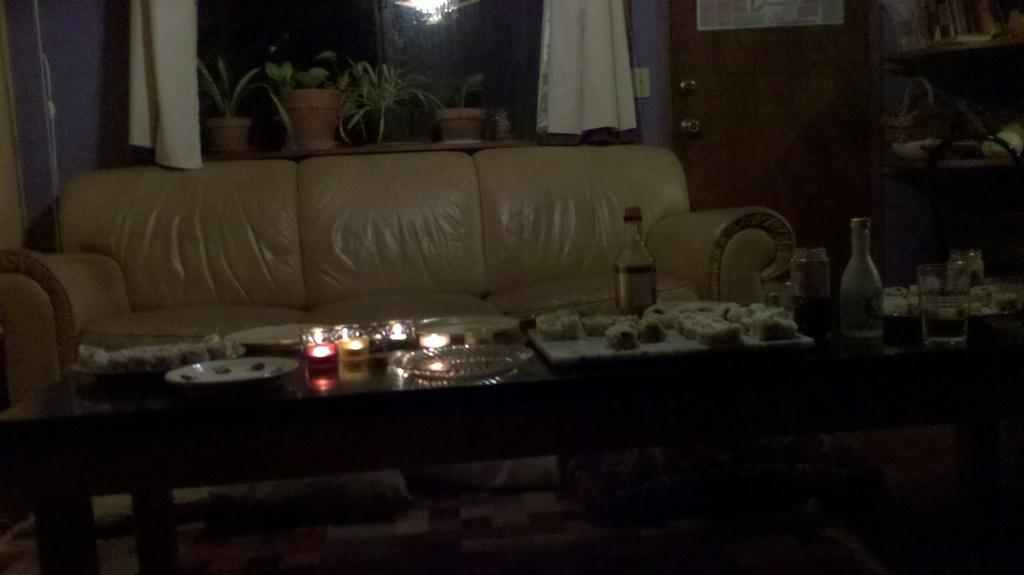What type of furniture is in the image? There is a couch in the image. What can be seen on the table in the image? There are plates, a candle, and a bottle on the table in the image. What is in the background of the image? There is a flower pot, a curtain, and a door in the background. What type of zinc is present in the image? There is no zinc present in the image. Can you recite the verse that is written on the curtain in the image? There is no verse written on the curtain in the image. 